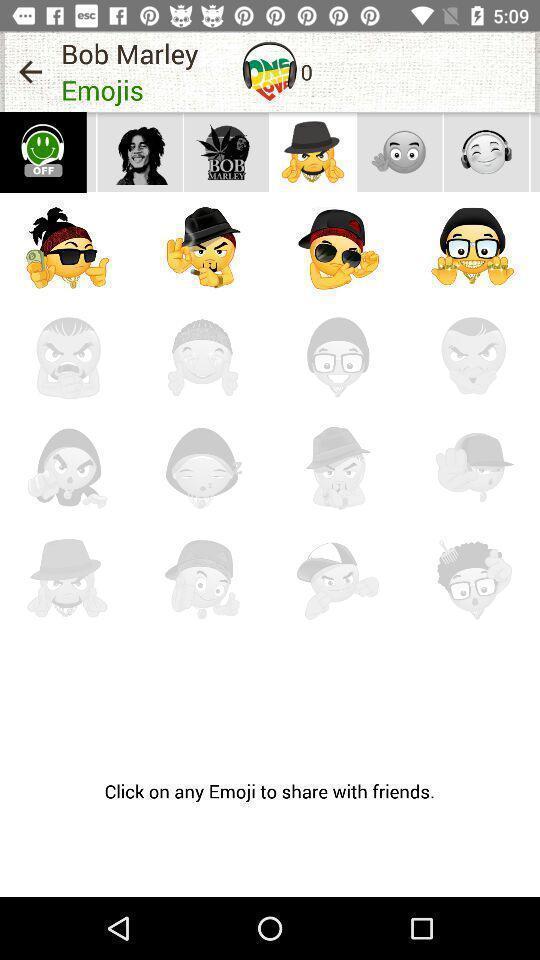What details can you identify in this image? Screen showing various emojis in social app. 